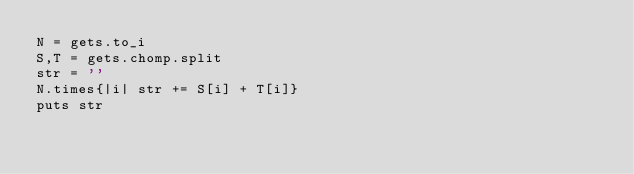Convert code to text. <code><loc_0><loc_0><loc_500><loc_500><_Ruby_>N = gets.to_i
S,T = gets.chomp.split
str = ''
N.times{|i| str += S[i] + T[i]}
puts str</code> 